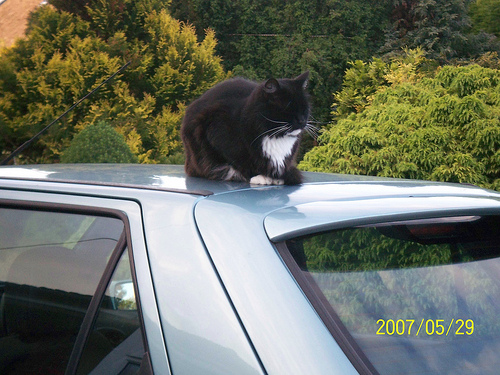<image>
Is the cat to the left of the car? No. The cat is not to the left of the car. From this viewpoint, they have a different horizontal relationship. 